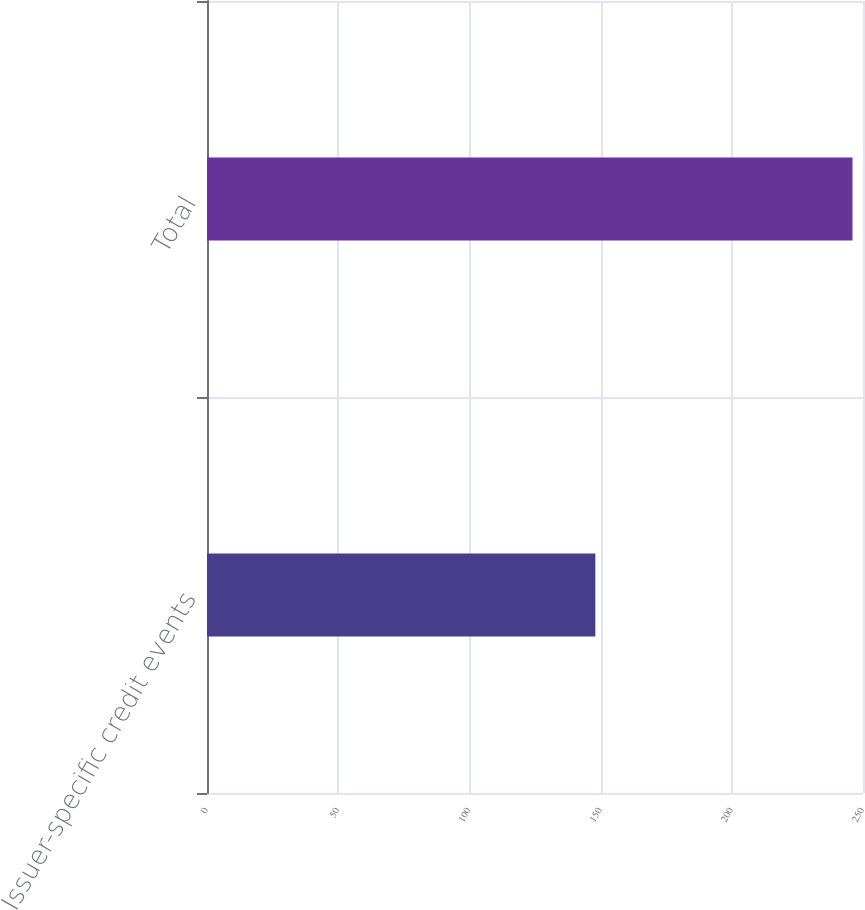Convert chart. <chart><loc_0><loc_0><loc_500><loc_500><bar_chart><fcel>Issuer-specific credit events<fcel>Total<nl><fcel>148<fcel>246<nl></chart> 